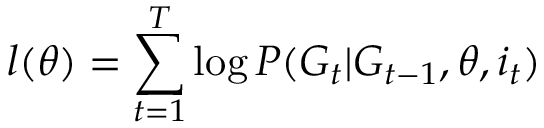Convert formula to latex. <formula><loc_0><loc_0><loc_500><loc_500>l ( \theta ) = \sum _ { t = 1 } ^ { T } \log P ( G _ { t } | G _ { t - 1 } , \theta , i _ { t } )</formula> 